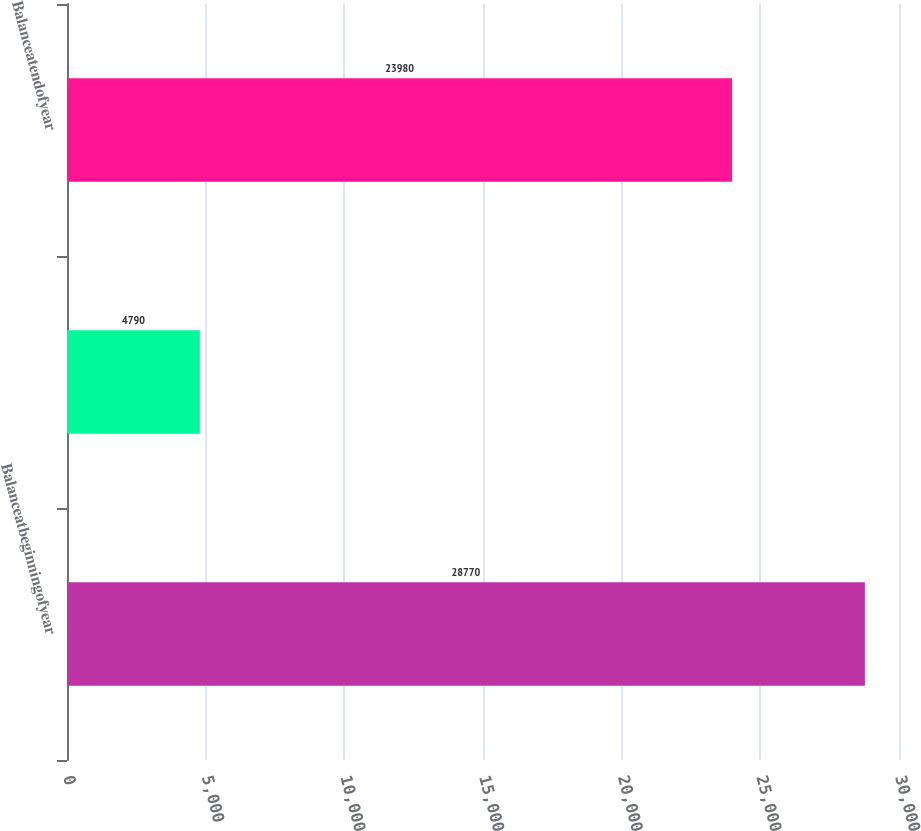<chart> <loc_0><loc_0><loc_500><loc_500><bar_chart><fcel>Balanceatbeginningofyear<fcel>Unnamed: 1<fcel>Balanceatendofyear<nl><fcel>28770<fcel>4790<fcel>23980<nl></chart> 